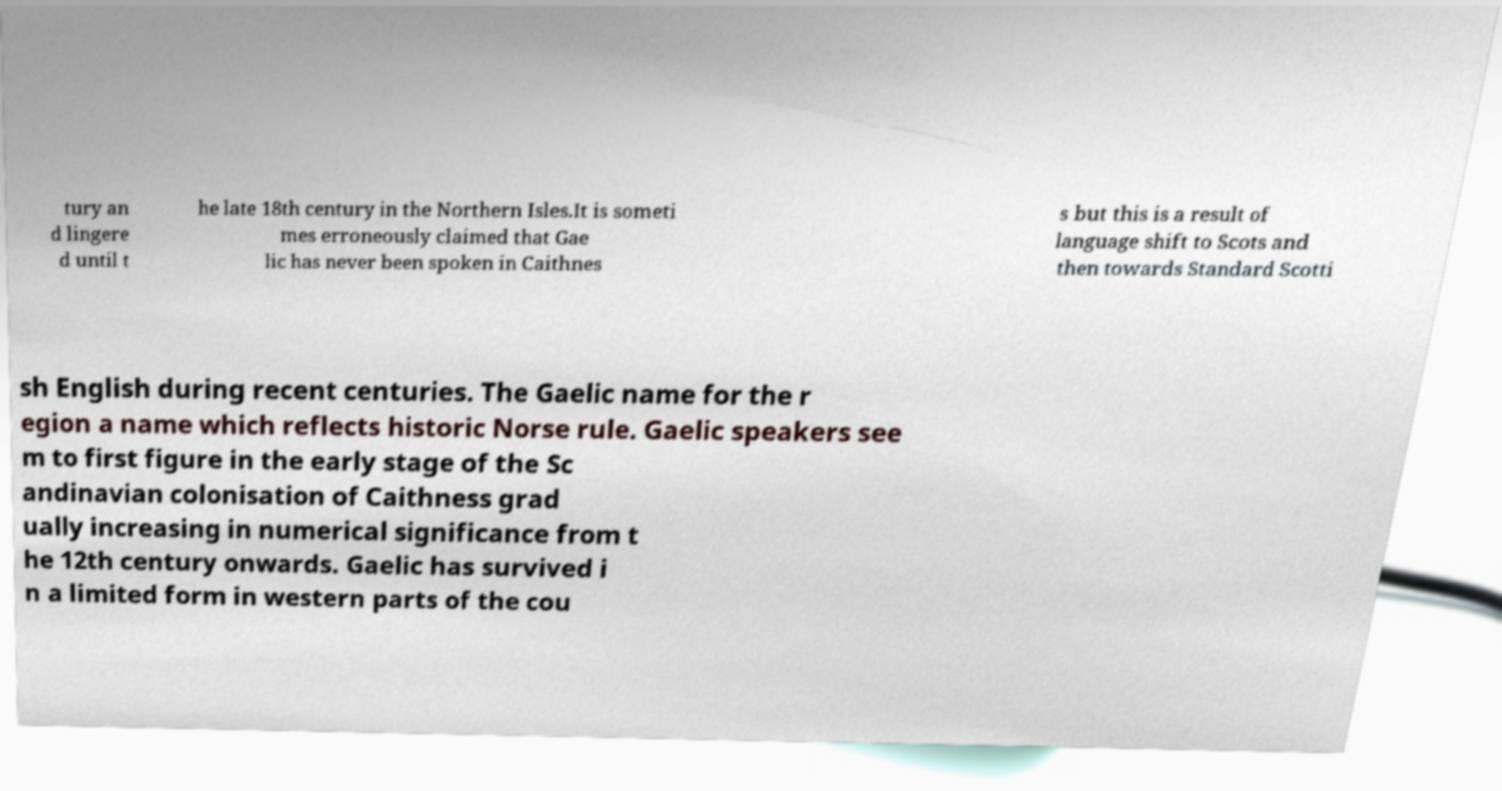Can you accurately transcribe the text from the provided image for me? tury an d lingere d until t he late 18th century in the Northern Isles.It is someti mes erroneously claimed that Gae lic has never been spoken in Caithnes s but this is a result of language shift to Scots and then towards Standard Scotti sh English during recent centuries. The Gaelic name for the r egion a name which reflects historic Norse rule. Gaelic speakers see m to first figure in the early stage of the Sc andinavian colonisation of Caithness grad ually increasing in numerical significance from t he 12th century onwards. Gaelic has survived i n a limited form in western parts of the cou 